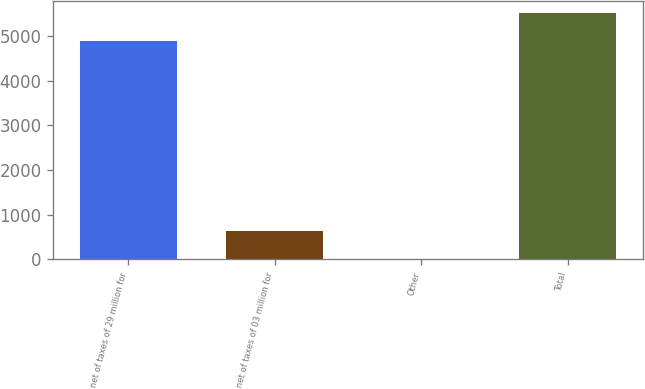<chart> <loc_0><loc_0><loc_500><loc_500><bar_chart><fcel>net of taxes of 29 million for<fcel>net of taxes of 03 million for<fcel>Other<fcel>Total<nl><fcel>4890<fcel>628<fcel>9<fcel>5509<nl></chart> 